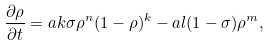Convert formula to latex. <formula><loc_0><loc_0><loc_500><loc_500>\frac { \partial \rho } { \partial t } = a k \sigma \rho ^ { n } ( 1 - \rho ) ^ { k } - a l ( 1 - \sigma ) \rho ^ { m } ,</formula> 